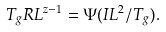<formula> <loc_0><loc_0><loc_500><loc_500>T _ { g } R L ^ { z - 1 } = \Psi ( I L ^ { 2 } / T _ { g } ) .</formula> 